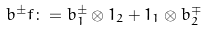<formula> <loc_0><loc_0><loc_500><loc_500>b ^ { \pm } f \colon = b _ { 1 } ^ { \pm } \otimes 1 _ { 2 } + 1 _ { 1 } \otimes b _ { 2 } ^ { \mp }</formula> 